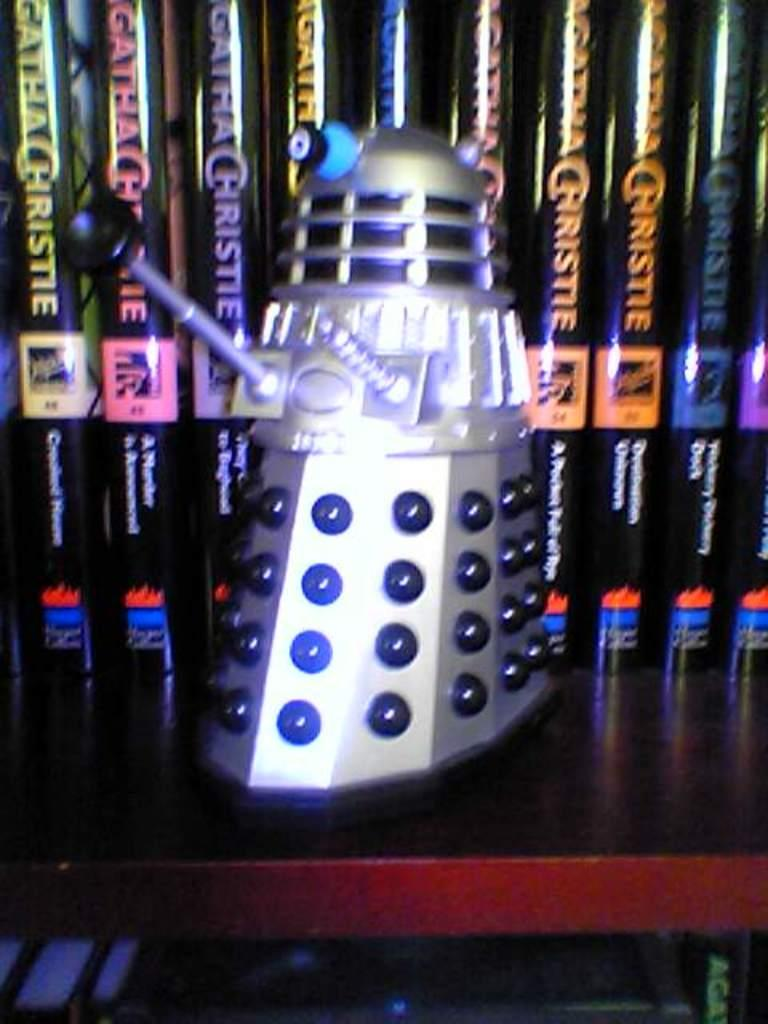Provide a one-sentence caption for the provided image. A dalek in front of a row of Agatha Christie novels. 